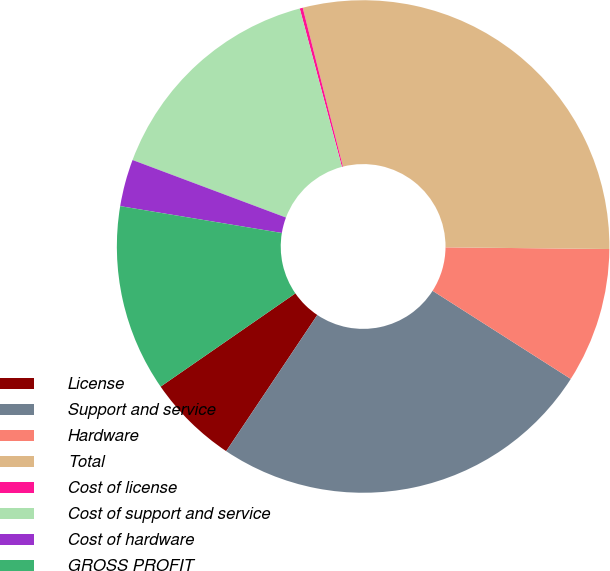<chart> <loc_0><loc_0><loc_500><loc_500><pie_chart><fcel>License<fcel>Support and service<fcel>Hardware<fcel>Total<fcel>Cost of license<fcel>Cost of support and service<fcel>Cost of hardware<fcel>GROSS PROFIT<nl><fcel>5.98%<fcel>25.34%<fcel>8.87%<fcel>29.1%<fcel>0.2%<fcel>15.14%<fcel>3.09%<fcel>12.25%<nl></chart> 